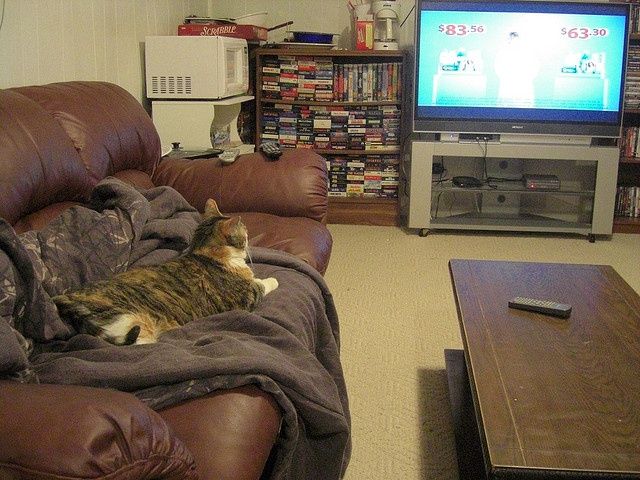Describe the objects in this image and their specific colors. I can see couch in tan, maroon, brown, and black tones, book in tan, black, white, and gray tones, tv in tan, white, cyan, and blue tones, cat in tan, olive, black, and gray tones, and microwave in tan and black tones in this image. 